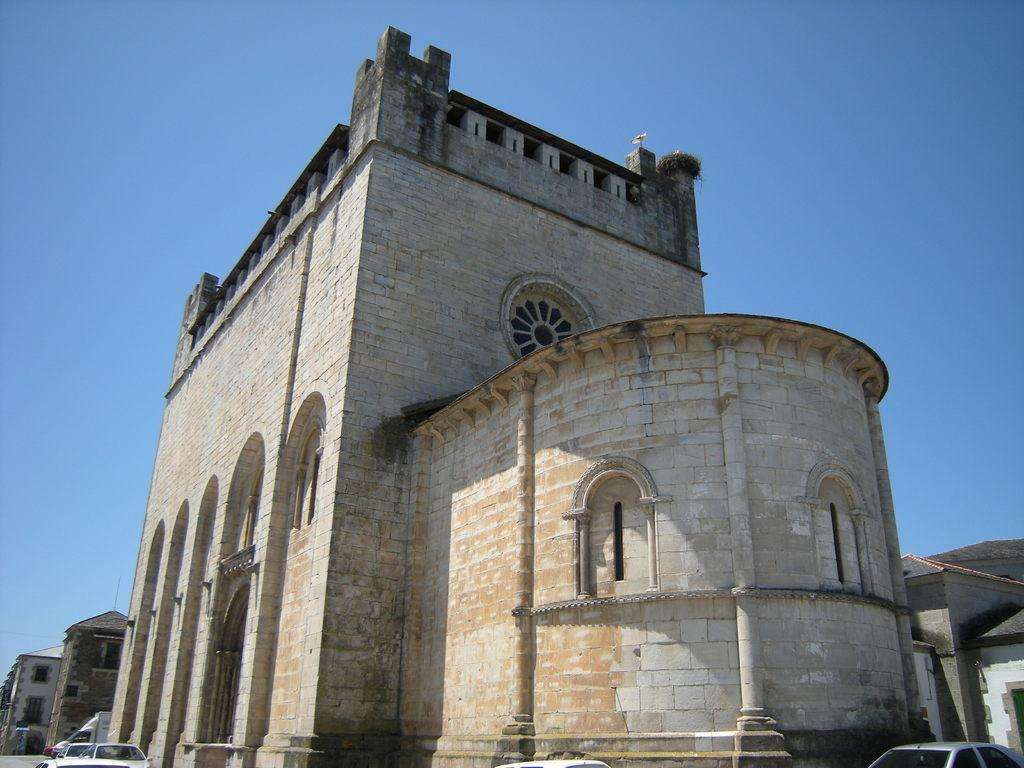What type of structures can be seen in the image? There are buildings in the image. What is happening on the road in the image? Cars are moving on the road in the image. How would you describe the sky in the image? The sky is blue and cloudy in the image. Can you see any signs of regret on the faces of the drivers in the image? There is no indication of the drivers' emotions or facial expressions in the image, so it cannot be determined if they are experiencing regret. 